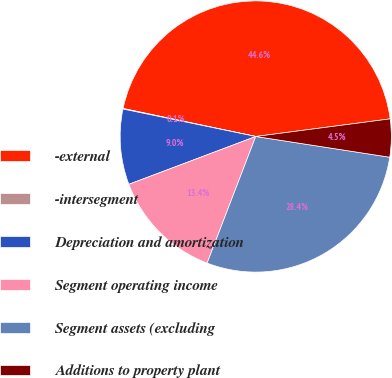Convert chart. <chart><loc_0><loc_0><loc_500><loc_500><pie_chart><fcel>-external<fcel>-intersegment<fcel>Depreciation and amortization<fcel>Segment operating income<fcel>Segment assets (excluding<fcel>Additions to property plant<nl><fcel>44.61%<fcel>0.07%<fcel>8.98%<fcel>13.43%<fcel>28.39%<fcel>4.52%<nl></chart> 